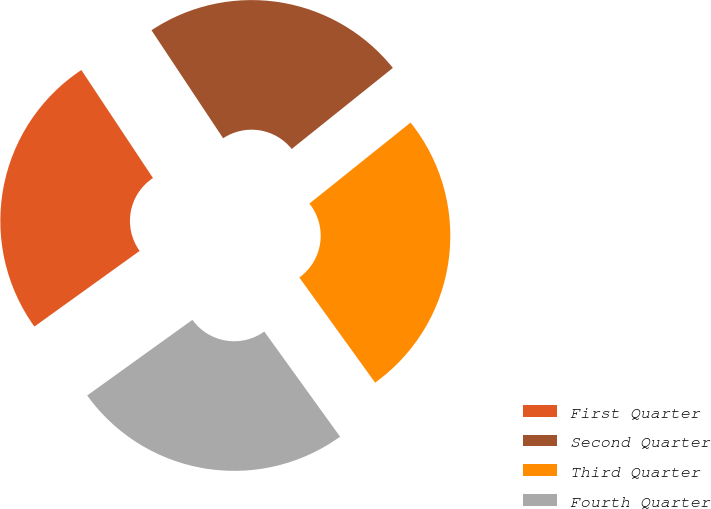Convert chart. <chart><loc_0><loc_0><loc_500><loc_500><pie_chart><fcel>First Quarter<fcel>Second Quarter<fcel>Third Quarter<fcel>Fourth Quarter<nl><fcel>25.6%<fcel>23.57%<fcel>25.81%<fcel>25.02%<nl></chart> 